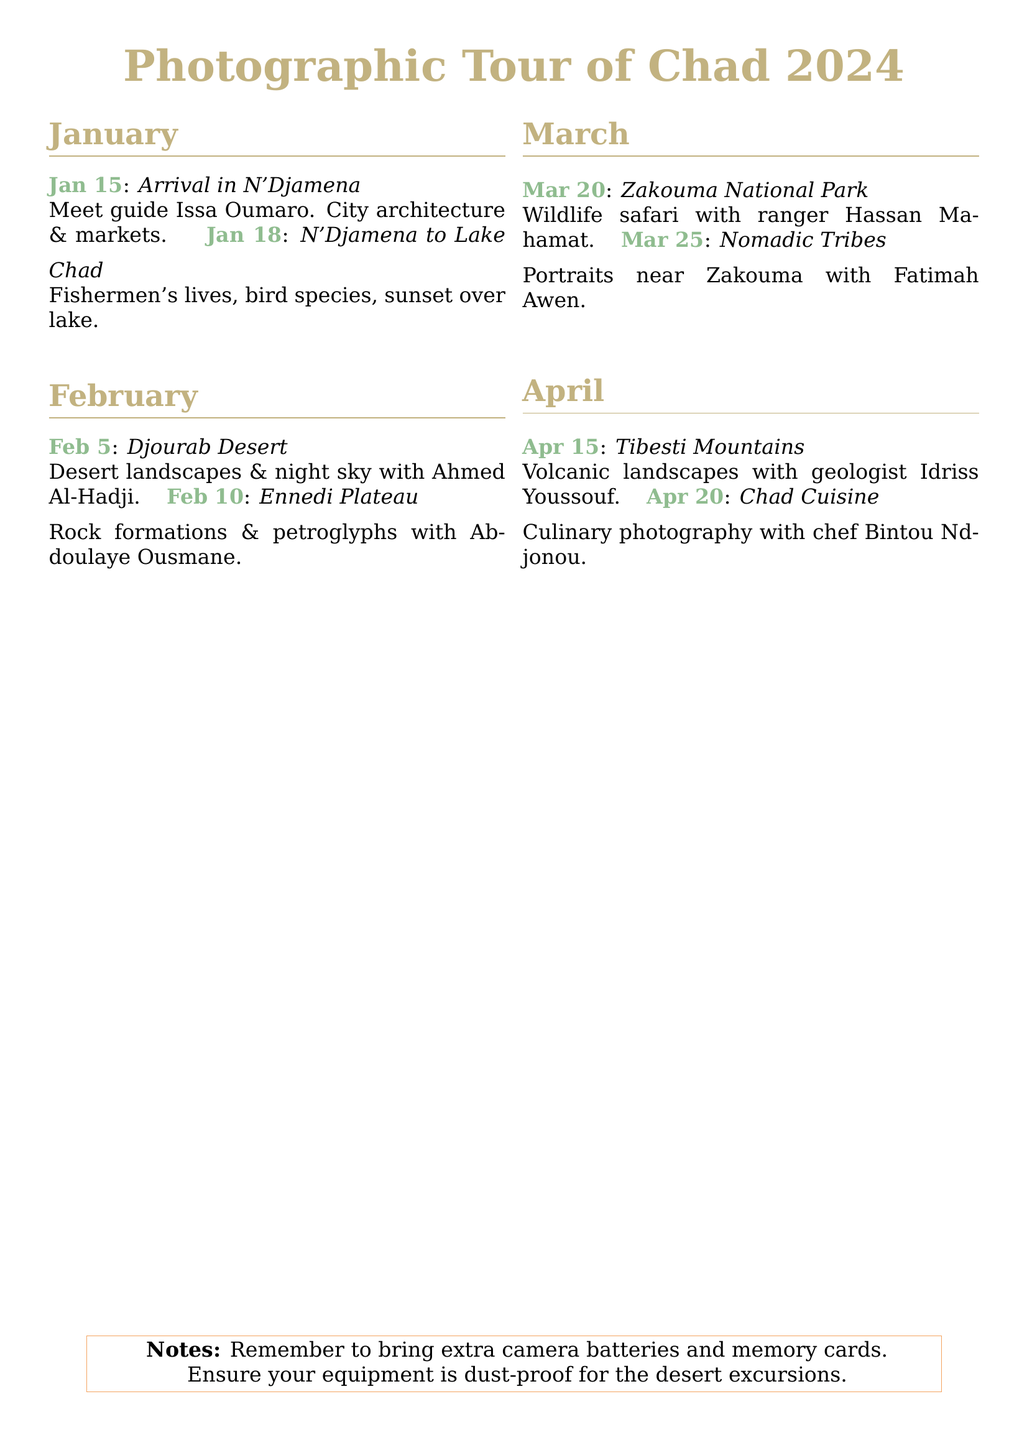What is the first event in the calendar? The first event is the arrival in N'Djamena on January 15.
Answer: Arrival in N'Djamena Who is the guide for the first event? The guide for the first event is Issa Oumaro.
Answer: Issa Oumaro What location is explored on February 10? The location explored on February 10 is the Ennedi Plateau.
Answer: Ennedi Plateau How many events are scheduled for March? There are two events scheduled for March.
Answer: 2 What is the main focus of the event on April 20? The main focus of the event on April 20 is culinary photography.
Answer: Culinary photography What type of photography is done at Lake Chad? The type of photography done at Lake Chad includes fishermen's lives and sunset over the lake.
Answer: Fishermen's lives, sunset Who leads the event in the Djourab Desert? The event in the Djourab Desert is led by Ahmed Al-Hadji.
Answer: Ahmed Al-Hadji What should participants remember to bring? Participants should remember to bring extra camera batteries and memory cards.
Answer: Extra camera batteries, memory cards 